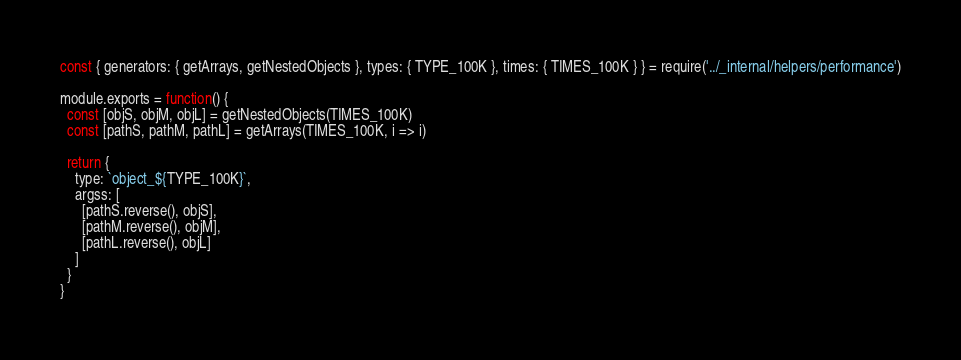<code> <loc_0><loc_0><loc_500><loc_500><_JavaScript_>const { generators: { getArrays, getNestedObjects }, types: { TYPE_100K }, times: { TIMES_100K } } = require('../_internal/helpers/performance')

module.exports = function() {
  const [objS, objM, objL] = getNestedObjects(TIMES_100K)
  const [pathS, pathM, pathL] = getArrays(TIMES_100K, i => i)

  return {
    type: `object_${TYPE_100K}`,
    argss: [
      [pathS.reverse(), objS],
      [pathM.reverse(), objM],
      [pathL.reverse(), objL]
    ]
  }
}
</code> 